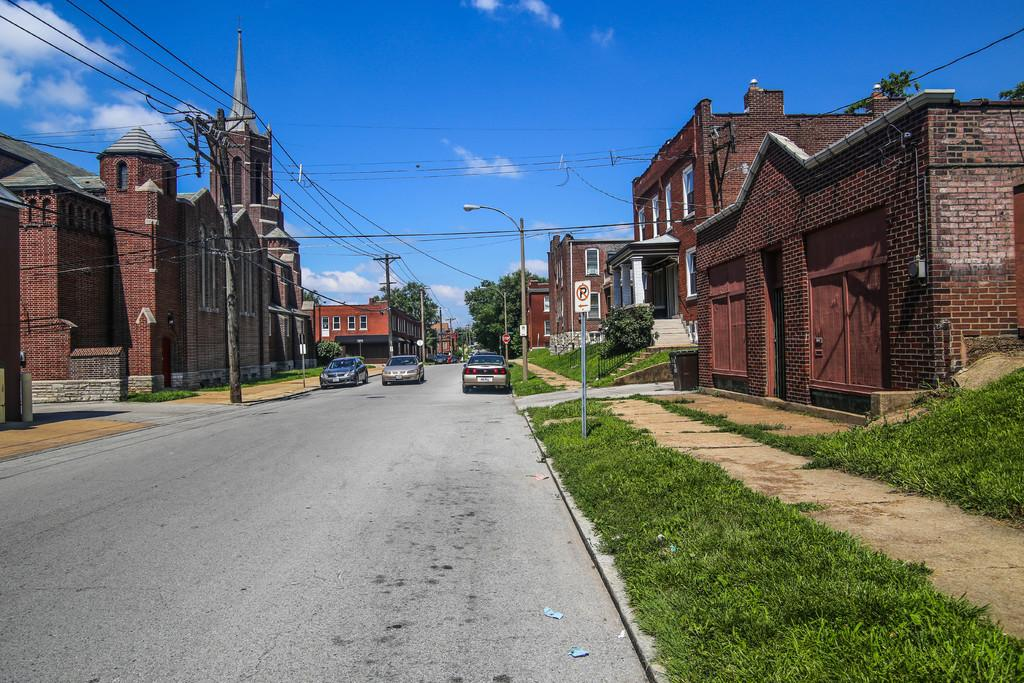Provide a one-sentence caption for the provided image. a no parking sign on the side of a very large street. 